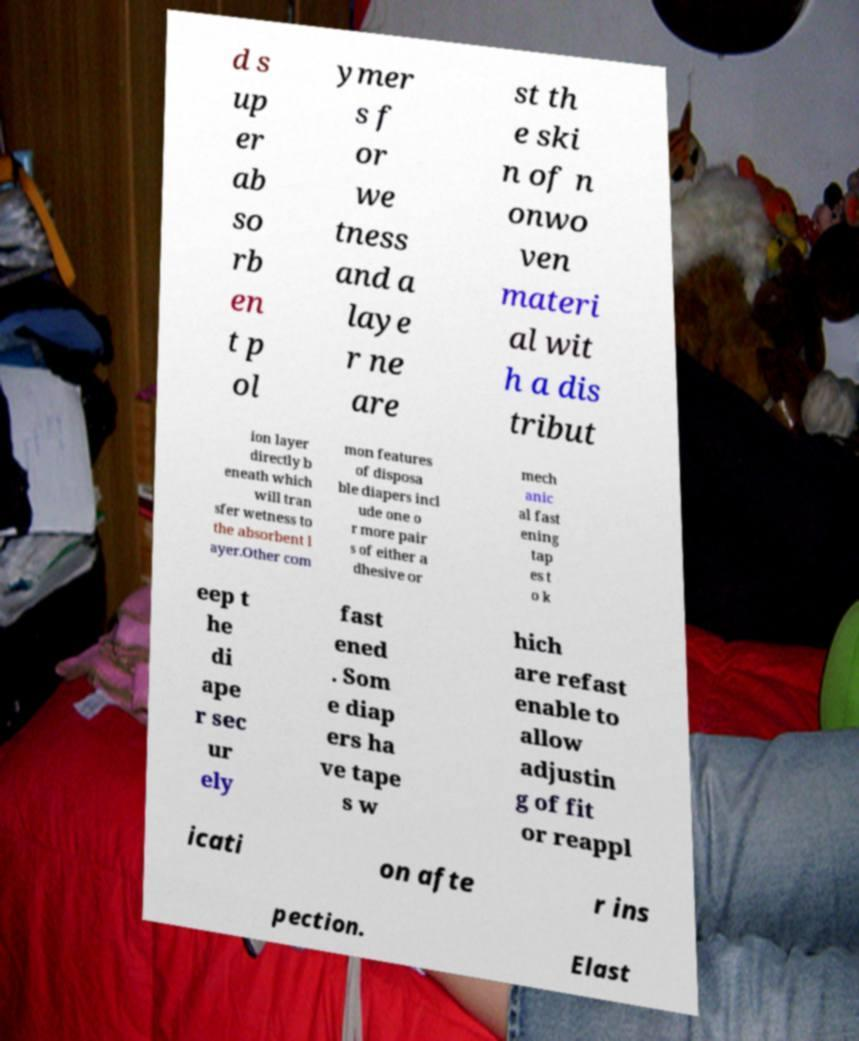Please read and relay the text visible in this image. What does it say? d s up er ab so rb en t p ol ymer s f or we tness and a laye r ne are st th e ski n of n onwo ven materi al wit h a dis tribut ion layer directly b eneath which will tran sfer wetness to the absorbent l ayer.Other com mon features of disposa ble diapers incl ude one o r more pair s of either a dhesive or mech anic al fast ening tap es t o k eep t he di ape r sec ur ely fast ened . Som e diap ers ha ve tape s w hich are refast enable to allow adjustin g of fit or reappl icati on afte r ins pection. Elast 